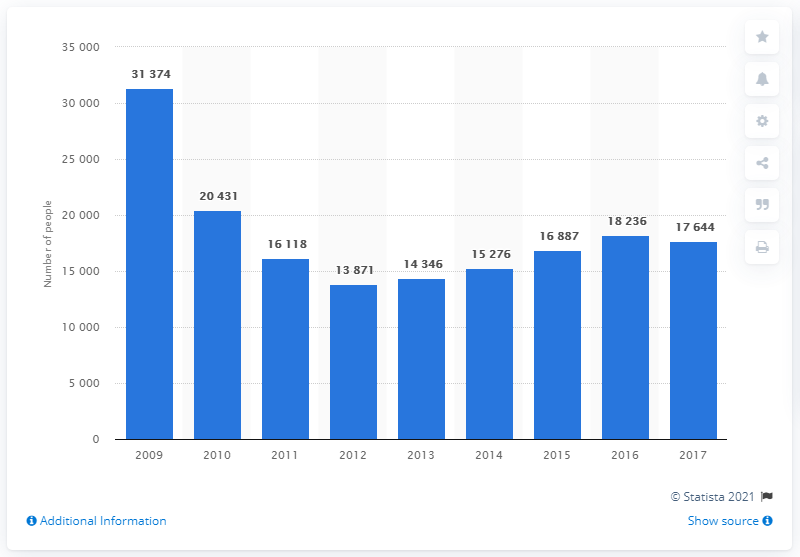Specify some key components in this picture. In 2012, a total of 13,871 individuals were refused entry at a UK port and subsequently deported. 